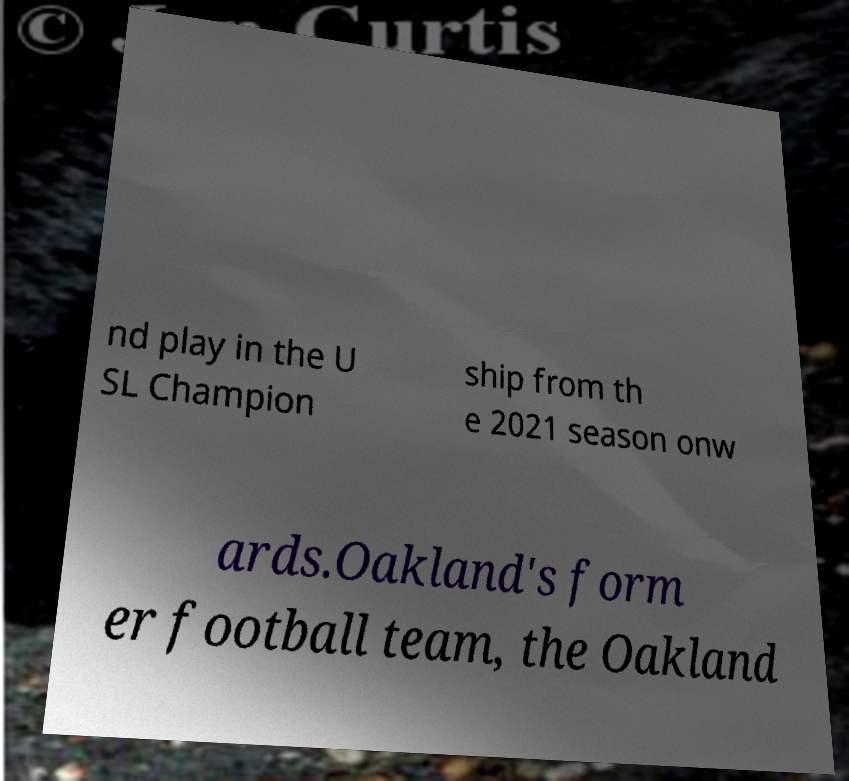Can you accurately transcribe the text from the provided image for me? nd play in the U SL Champion ship from th e 2021 season onw ards.Oakland's form er football team, the Oakland 